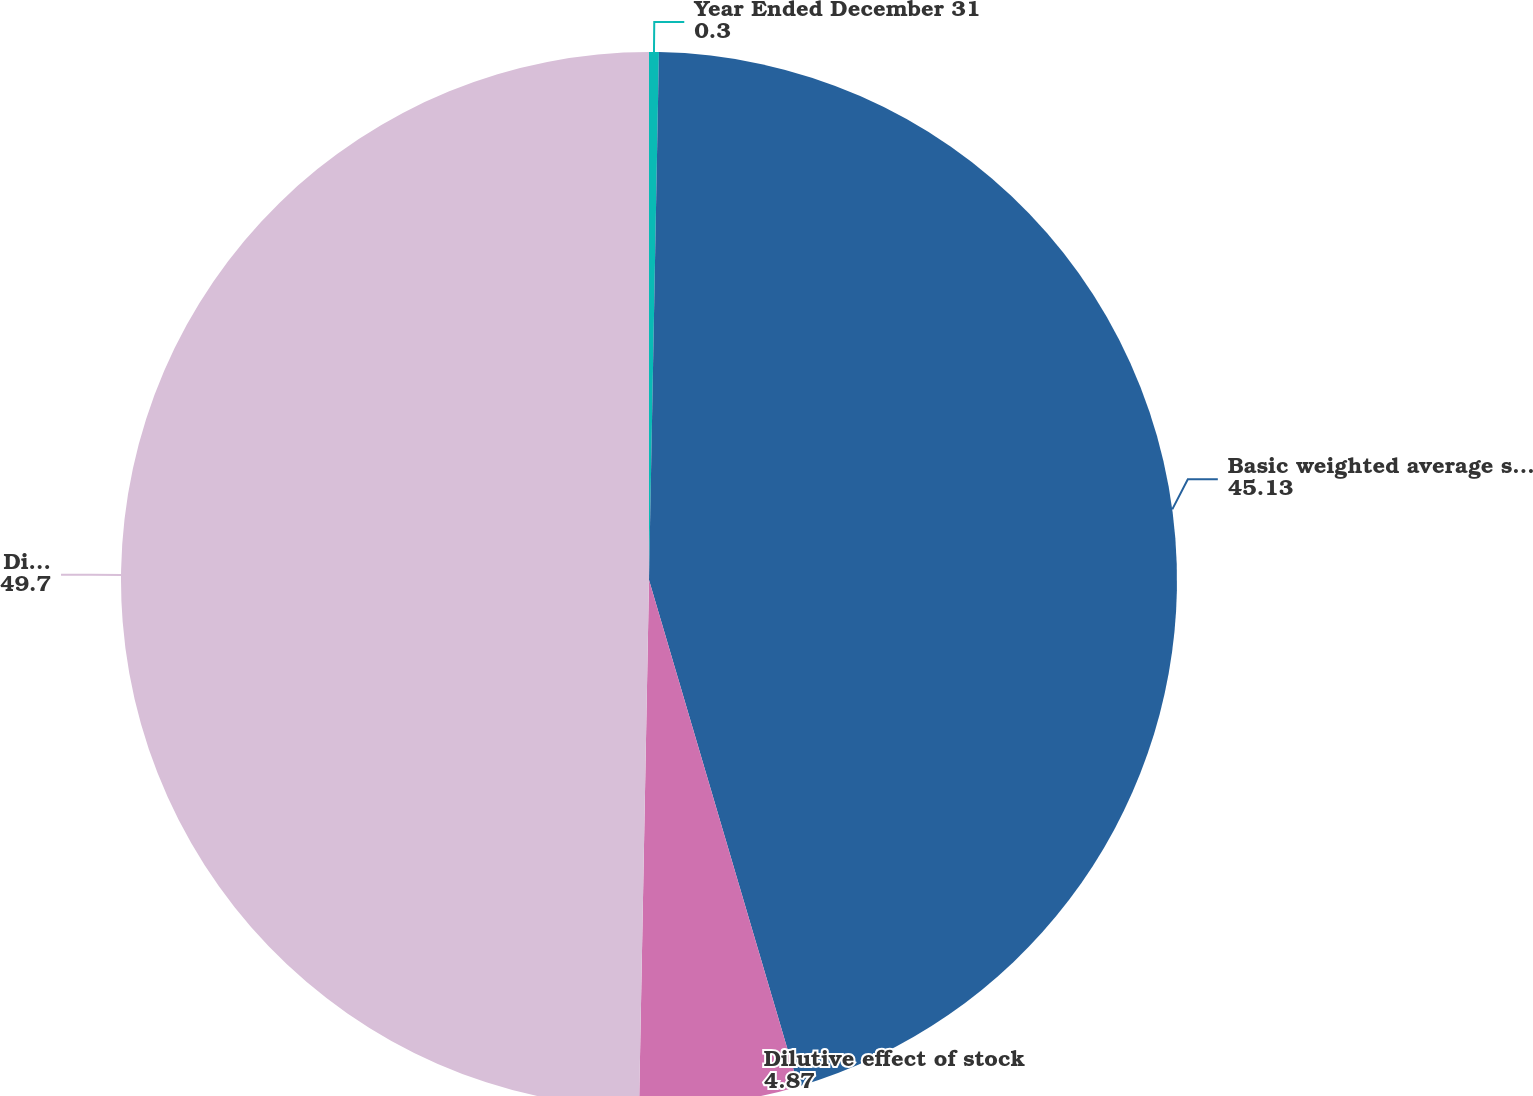Convert chart to OTSL. <chart><loc_0><loc_0><loc_500><loc_500><pie_chart><fcel>Year Ended December 31<fcel>Basic weighted average shares<fcel>Dilutive effect of stock<fcel>Diluted weighted average<nl><fcel>0.3%<fcel>45.13%<fcel>4.87%<fcel>49.7%<nl></chart> 